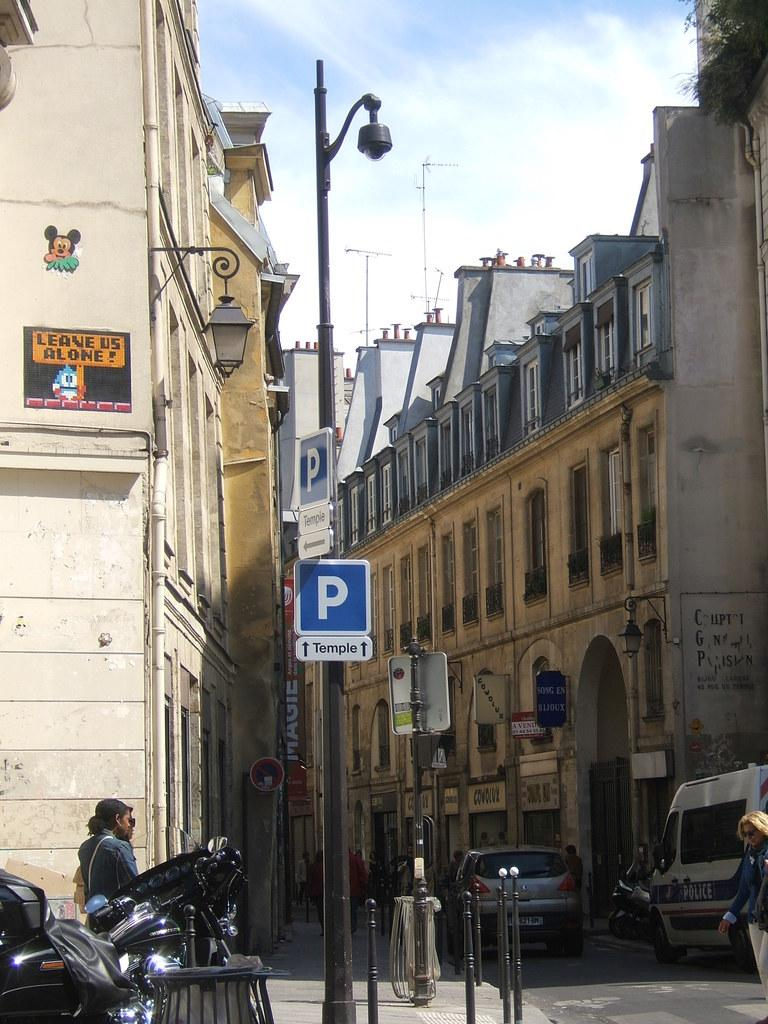What type of structures can be seen in the image? There are buildings in the image. What objects are emitting light in the image? There are lights in the image. What type of signage is present in the image? There are boards in the image. What type of vertical structures are present in the image? There are poles in the image. What type of natural elements can be seen in the image? There are plants in the image. What type of living beings can be seen in the image? There are people in the image. What type of transportation is present in the image? There are vehicles in the image. What is visible in the background of the image? The sky is visible in the background of the image. What atmospheric elements can be seen in the sky? Clouds are present in the sky. What type of wood can be seen in the image? There is no wood present in the image. What type of kite is being flown by the people in the image? There are no kites present in the image. 